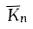<formula> <loc_0><loc_0><loc_500><loc_500>\overline { K } _ { n }</formula> 